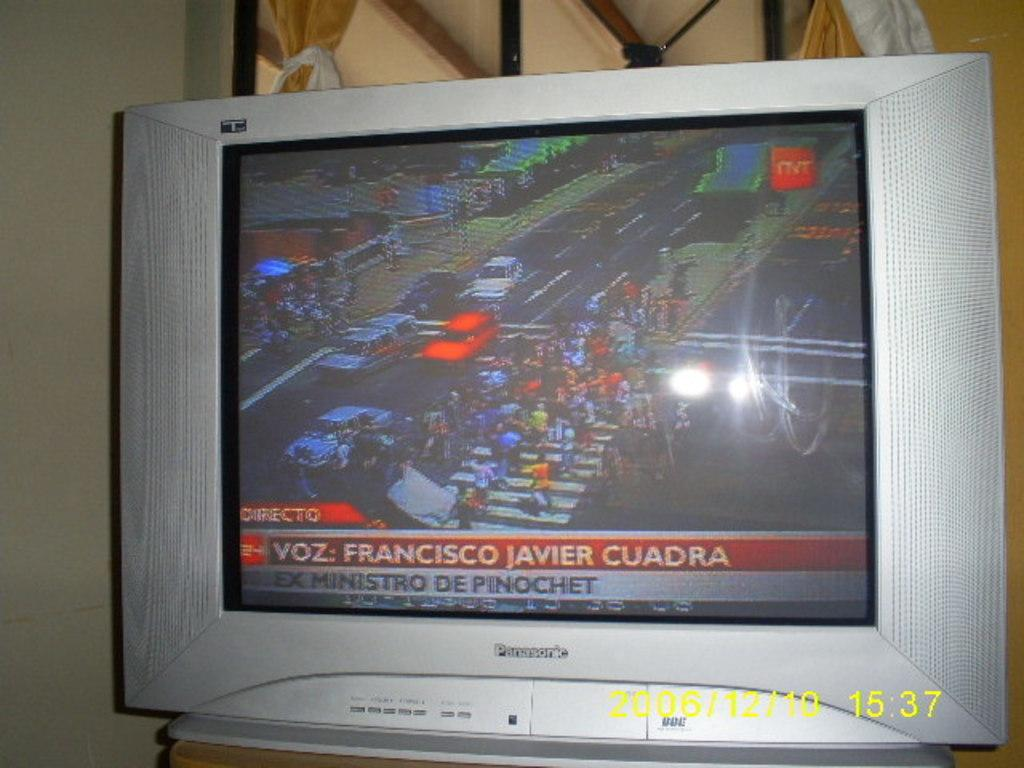Provide a one-sentence caption for the provided image. A Panasonic tv monitor shows people on a crosswalk. 